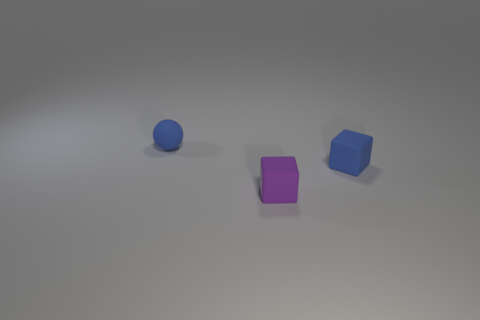Are there more blue cubes in front of the tiny blue rubber block than small purple cubes in front of the purple matte block?
Your response must be concise. No. There is a purple block that is the same size as the blue rubber ball; what is its material?
Provide a succinct answer. Rubber. What is the shape of the tiny purple matte thing?
Provide a short and direct response. Cube. What number of purple objects are either tiny matte blocks or tiny spheres?
Your response must be concise. 1. There is a blue ball that is the same material as the purple cube; what size is it?
Offer a very short reply. Small. Are the blue thing that is on the right side of the tiny matte ball and the small blue ball on the left side of the tiny purple cube made of the same material?
Your response must be concise. Yes. What number of balls are blue rubber things or big red matte objects?
Offer a terse response. 1. There is a object that is in front of the tiny blue object right of the small matte sphere; what number of tiny matte blocks are right of it?
Offer a terse response. 1. There is a tiny blue object that is the same shape as the purple rubber object; what is its material?
Offer a very short reply. Rubber. Is there anything else that has the same material as the tiny purple block?
Your response must be concise. Yes. 